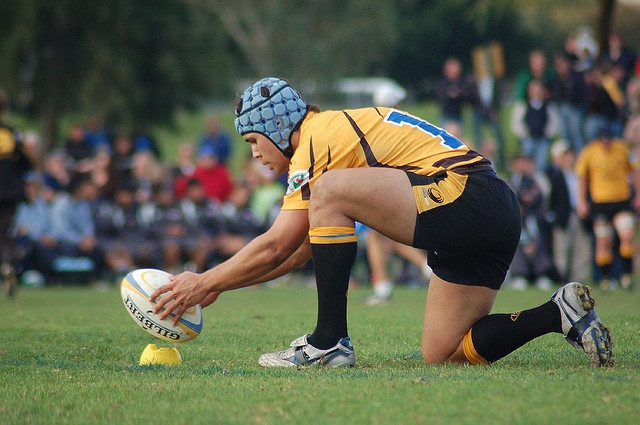Describe the objects in this image and their specific colors. I can see people in black, brown, tan, and gray tones, people in black, gray, and brown tones, people in black, olive, and gray tones, people in black and gray tones, and sports ball in black, ivory, darkgray, olive, and gray tones in this image. 